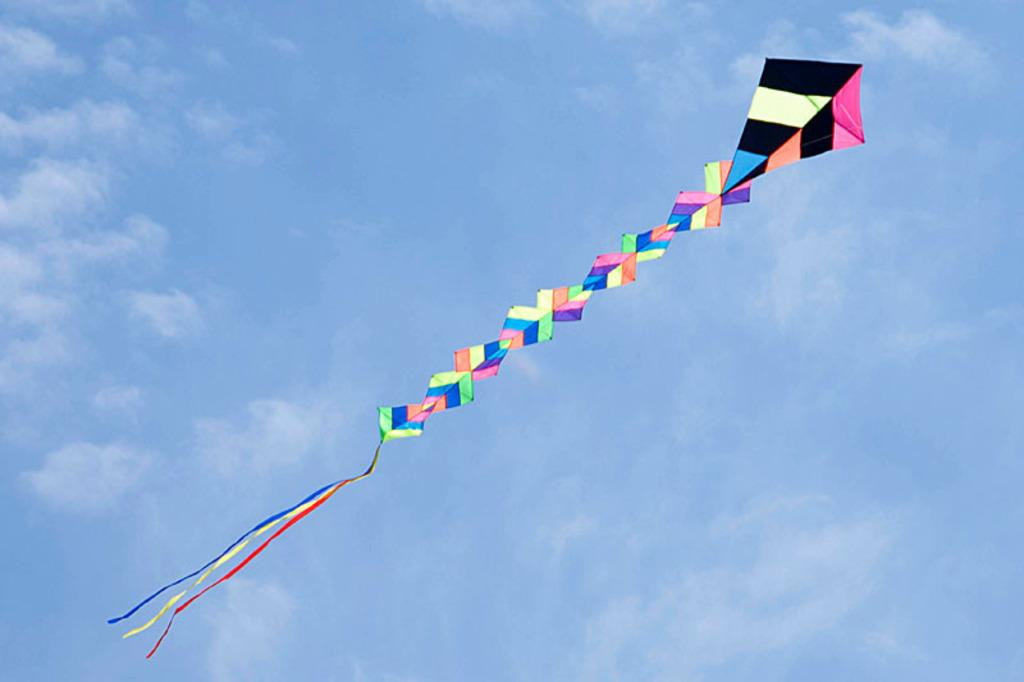What is the main subject of the image? The main subject of the image is a kite. What is the kite doing in the image? The kite is flying in the sky. Can you describe the appearance of the kite? The kite has multiple colors. How would you describe the weather based on the image? The sky is cloudy. What type of screw is holding the kite together in the image? There is no screw visible in the image; it is a kite flying in the sky. What brand of jeans is the person wearing who is flying the kite in the image? There is no person visible in the image, only the kite flying in the sky. 